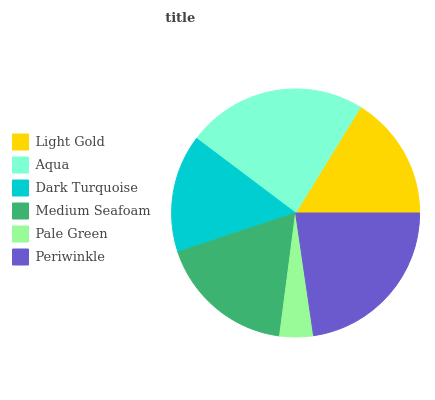Is Pale Green the minimum?
Answer yes or no. Yes. Is Aqua the maximum?
Answer yes or no. Yes. Is Dark Turquoise the minimum?
Answer yes or no. No. Is Dark Turquoise the maximum?
Answer yes or no. No. Is Aqua greater than Dark Turquoise?
Answer yes or no. Yes. Is Dark Turquoise less than Aqua?
Answer yes or no. Yes. Is Dark Turquoise greater than Aqua?
Answer yes or no. No. Is Aqua less than Dark Turquoise?
Answer yes or no. No. Is Medium Seafoam the high median?
Answer yes or no. Yes. Is Light Gold the low median?
Answer yes or no. Yes. Is Aqua the high median?
Answer yes or no. No. Is Aqua the low median?
Answer yes or no. No. 